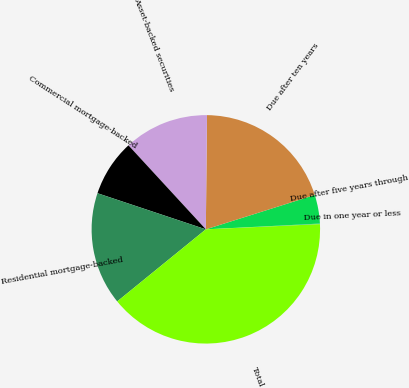Convert chart. <chart><loc_0><loc_0><loc_500><loc_500><pie_chart><fcel>Due in one year or less<fcel>Due after five years through<fcel>Due after ten years<fcel>Asset-backed securities<fcel>Commercial mortgage-backed<fcel>Residential mortgage-backed<fcel>Total<nl><fcel>0.08%<fcel>4.06%<fcel>19.97%<fcel>12.01%<fcel>8.03%<fcel>15.99%<fcel>39.86%<nl></chart> 